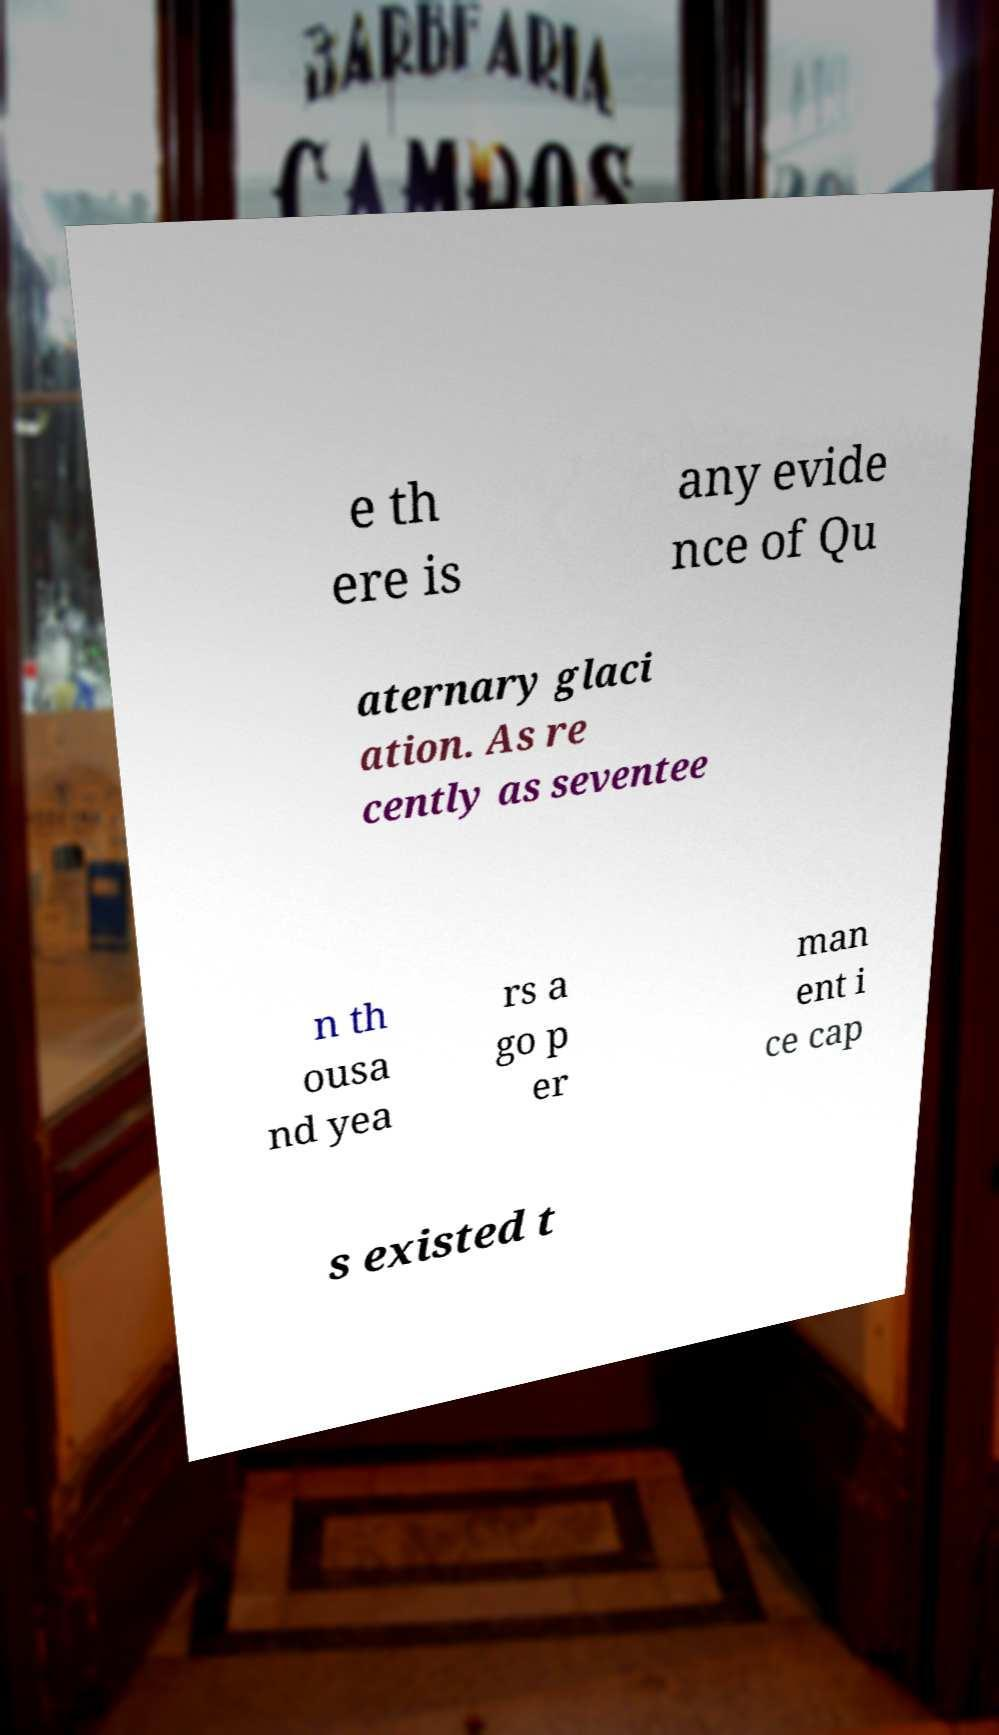For documentation purposes, I need the text within this image transcribed. Could you provide that? e th ere is any evide nce of Qu aternary glaci ation. As re cently as seventee n th ousa nd yea rs a go p er man ent i ce cap s existed t 